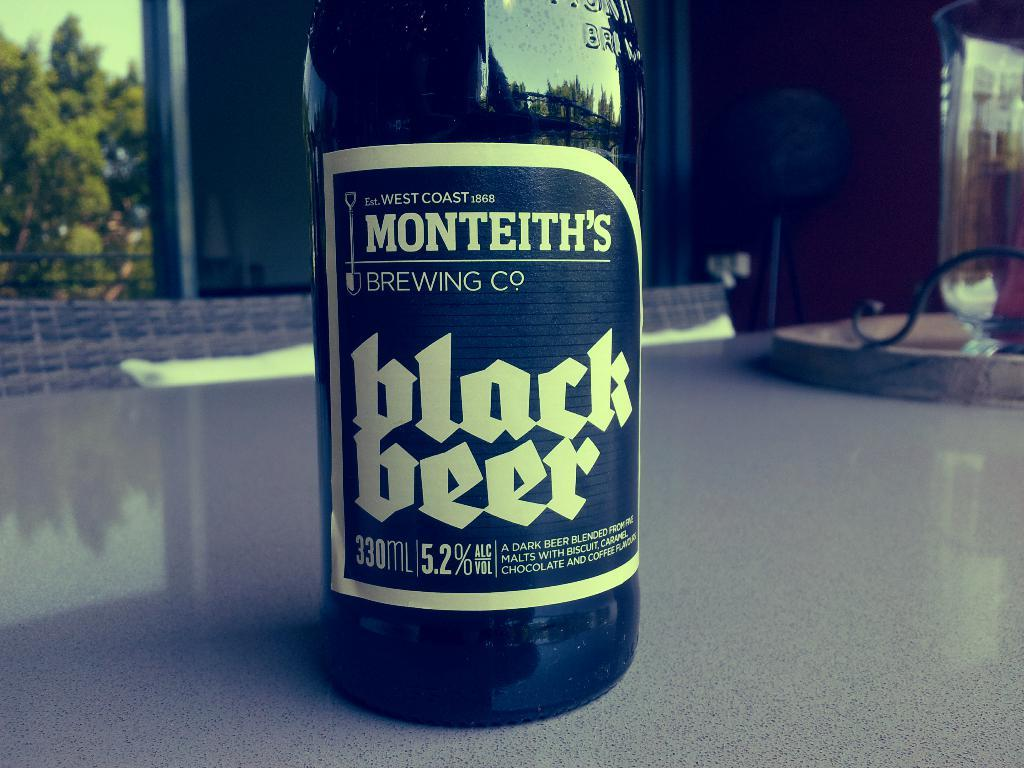<image>
Offer a succinct explanation of the picture presented. A bottle of Monteiths Black Beer sits on a counter. 